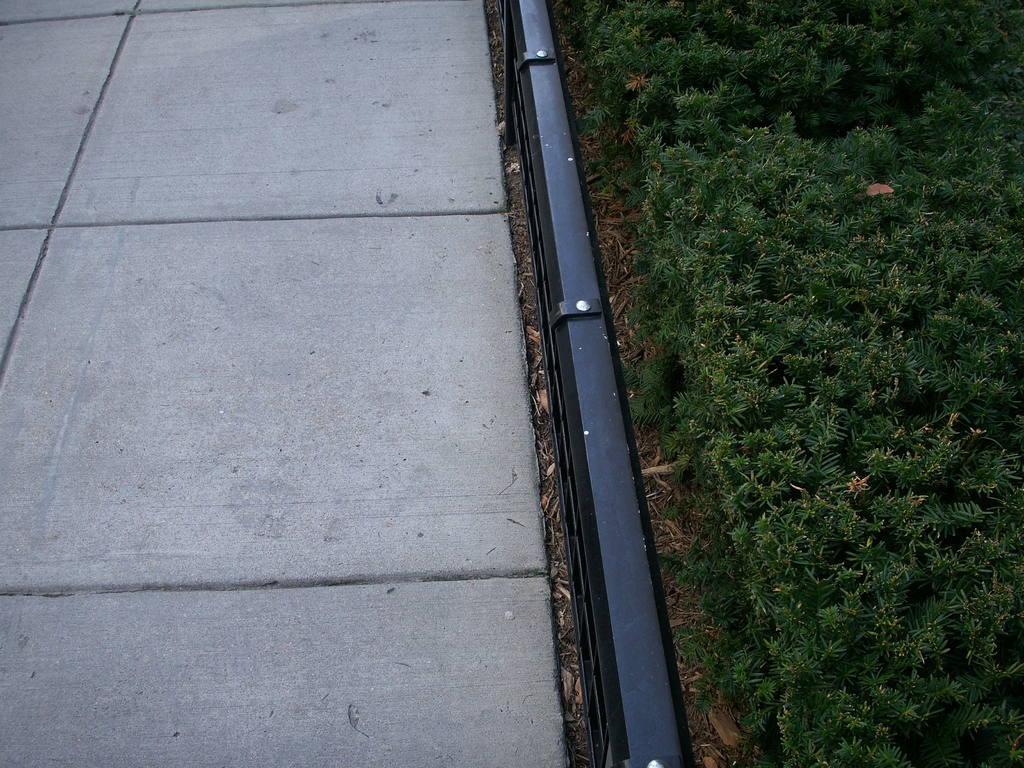In one or two sentences, can you explain what this image depicts? On the right side I can see the grass. In the middle there is a railing. On the left side, I can see the floor. 